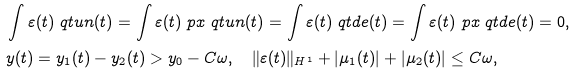<formula> <loc_0><loc_0><loc_500><loc_500>& \int \varepsilon ( t ) \ q t u n ( t ) = \int \varepsilon ( t ) \ p x \ q t u n ( t ) = \int \varepsilon ( t ) \ q t d e ( t ) = \int \varepsilon ( t ) \ p x \ q t d e ( t ) = 0 , \\ & y ( t ) = y _ { 1 } ( t ) - y _ { 2 } ( t ) > y _ { 0 } - C \omega , \quad \| \varepsilon ( t ) \| _ { H ^ { 1 } } + | \mu _ { 1 } ( t ) | + | \mu _ { 2 } ( t ) | \leq C \omega ,</formula> 